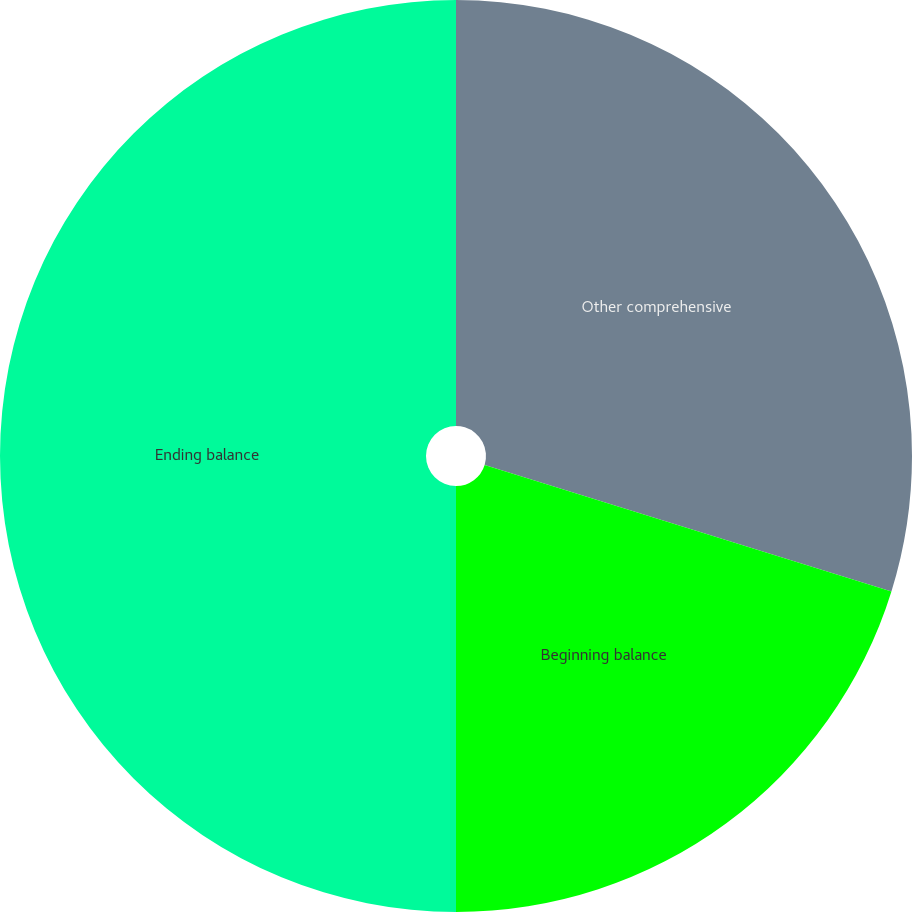<chart> <loc_0><loc_0><loc_500><loc_500><pie_chart><fcel>Other comprehensive<fcel>Beginning balance<fcel>Ending balance<nl><fcel>29.8%<fcel>20.2%<fcel>50.0%<nl></chart> 